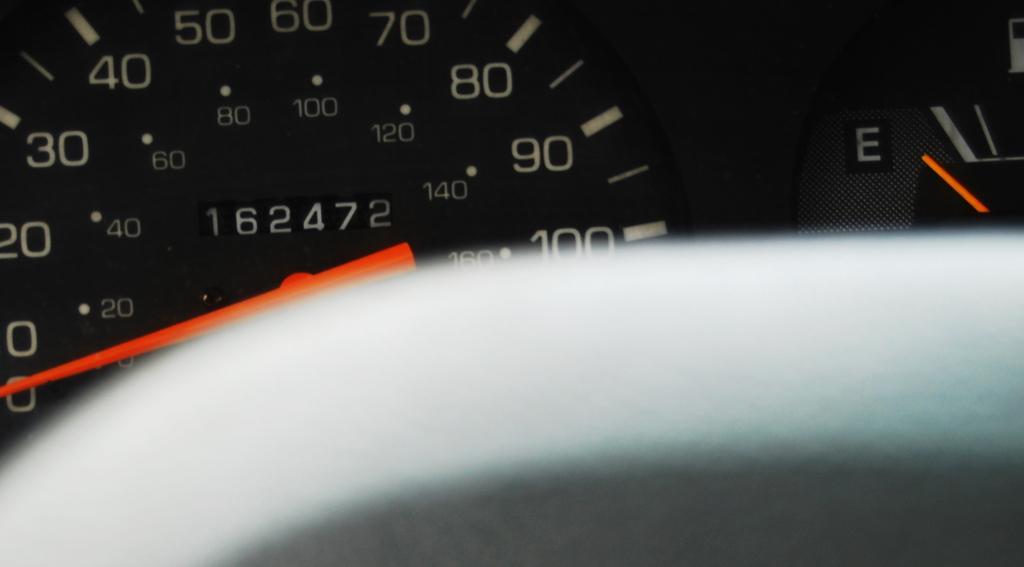How would you summarize this image in a sentence or two? This is a zoomed in picture. In the foreground there is a white color object seems to be the part of a steering wheel of a vehicle. In the background we can see the speedometer on which we can see the numbers. 